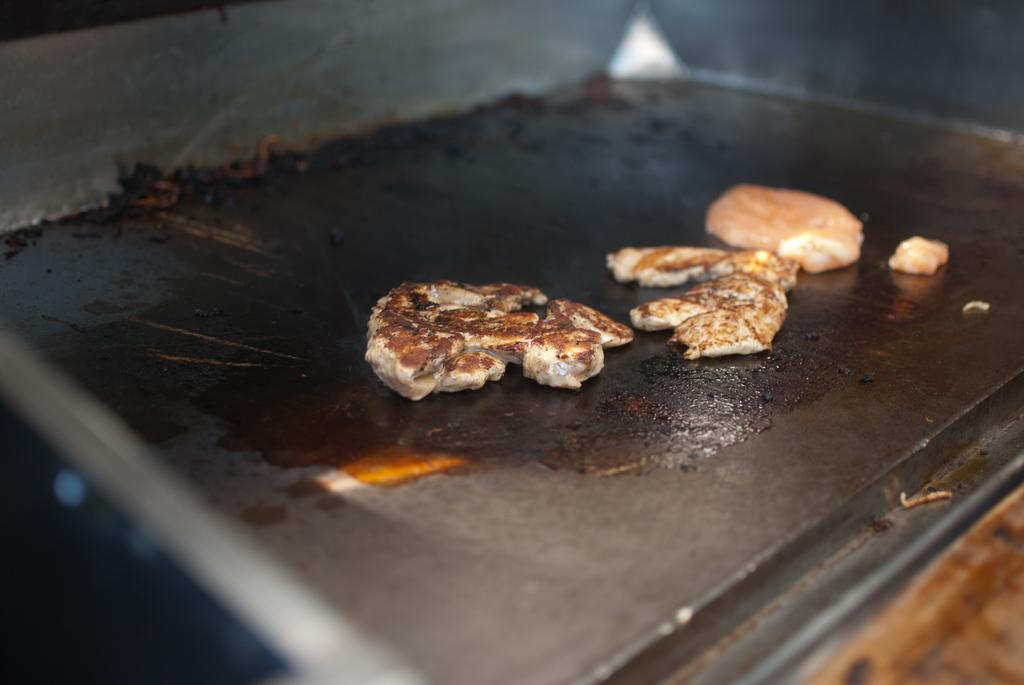What is present on the tray in the image? There is a tray in the image, and it contains a black object and cookies. Can you describe the black object on the tray? Unfortunately, the facts provided do not give any details about the black object on the tray. How many cookies are on the tray? The number of cookies on the tray is not specified in the provided facts. How does the tray make a joke in the image? The tray does not make a joke in the image; it is an inanimate object. 